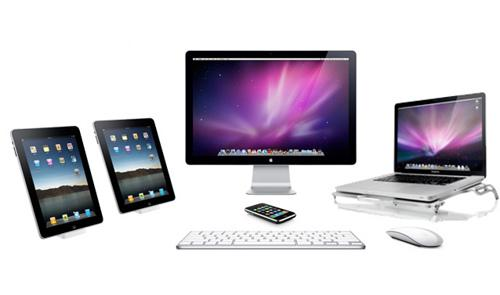What is in the middle? monitor 